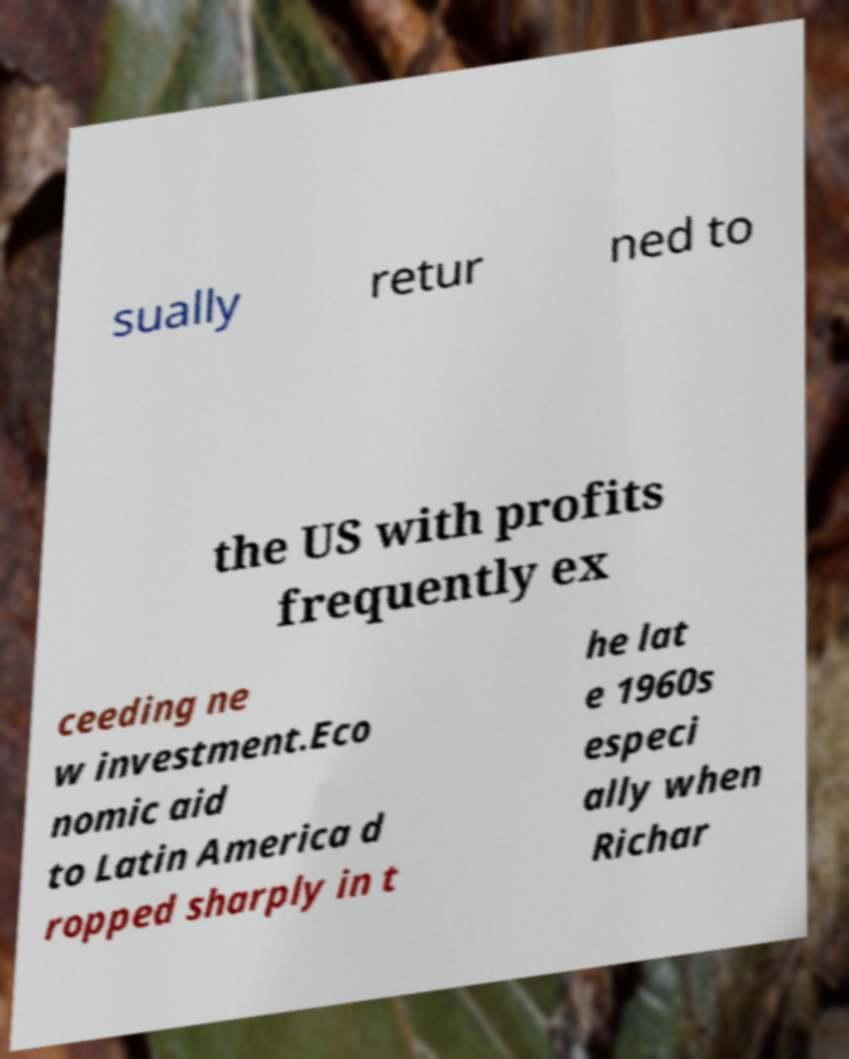There's text embedded in this image that I need extracted. Can you transcribe it verbatim? sually retur ned to the US with profits frequently ex ceeding ne w investment.Eco nomic aid to Latin America d ropped sharply in t he lat e 1960s especi ally when Richar 